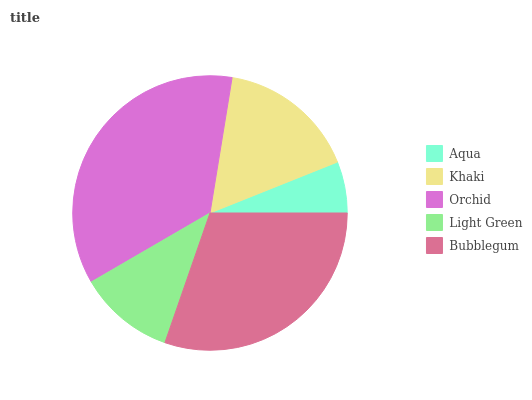Is Aqua the minimum?
Answer yes or no. Yes. Is Orchid the maximum?
Answer yes or no. Yes. Is Khaki the minimum?
Answer yes or no. No. Is Khaki the maximum?
Answer yes or no. No. Is Khaki greater than Aqua?
Answer yes or no. Yes. Is Aqua less than Khaki?
Answer yes or no. Yes. Is Aqua greater than Khaki?
Answer yes or no. No. Is Khaki less than Aqua?
Answer yes or no. No. Is Khaki the high median?
Answer yes or no. Yes. Is Khaki the low median?
Answer yes or no. Yes. Is Orchid the high median?
Answer yes or no. No. Is Light Green the low median?
Answer yes or no. No. 